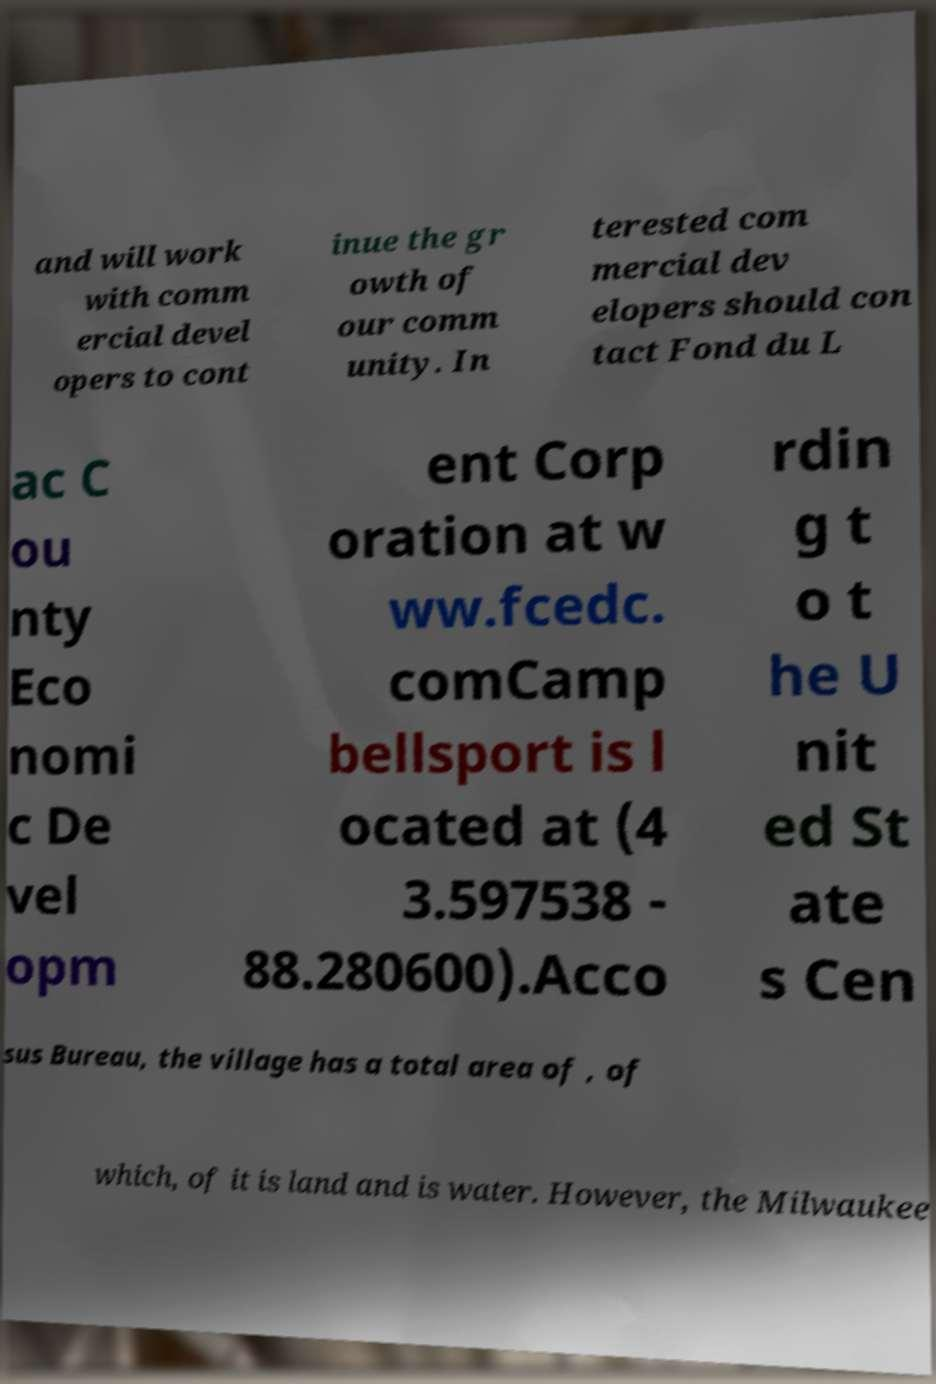What messages or text are displayed in this image? I need them in a readable, typed format. and will work with comm ercial devel opers to cont inue the gr owth of our comm unity. In terested com mercial dev elopers should con tact Fond du L ac C ou nty Eco nomi c De vel opm ent Corp oration at w ww.fcedc. comCamp bellsport is l ocated at (4 3.597538 - 88.280600).Acco rdin g t o t he U nit ed St ate s Cen sus Bureau, the village has a total area of , of which, of it is land and is water. However, the Milwaukee 